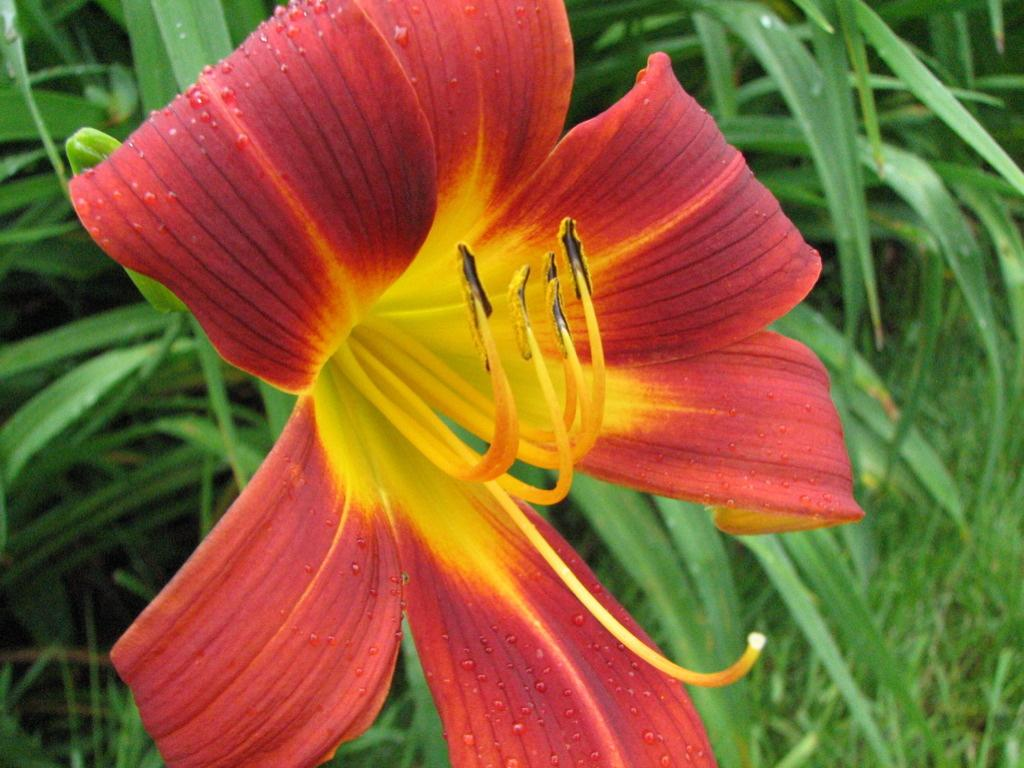What color is the flower in the image? The flower in the image is red and yellow. What can be seen in the background of the image? There are green leaves in the background of the image. What other color is present in the image besides red and yellow? There are yellow buds in the image. What type of cap is the flower wearing in the image? There is no cap present on the flower in the image. Can you describe the cellar where the flower is located in the image? There is no cellar mentioned or depicted in the image; it features a flower and green leaves. 